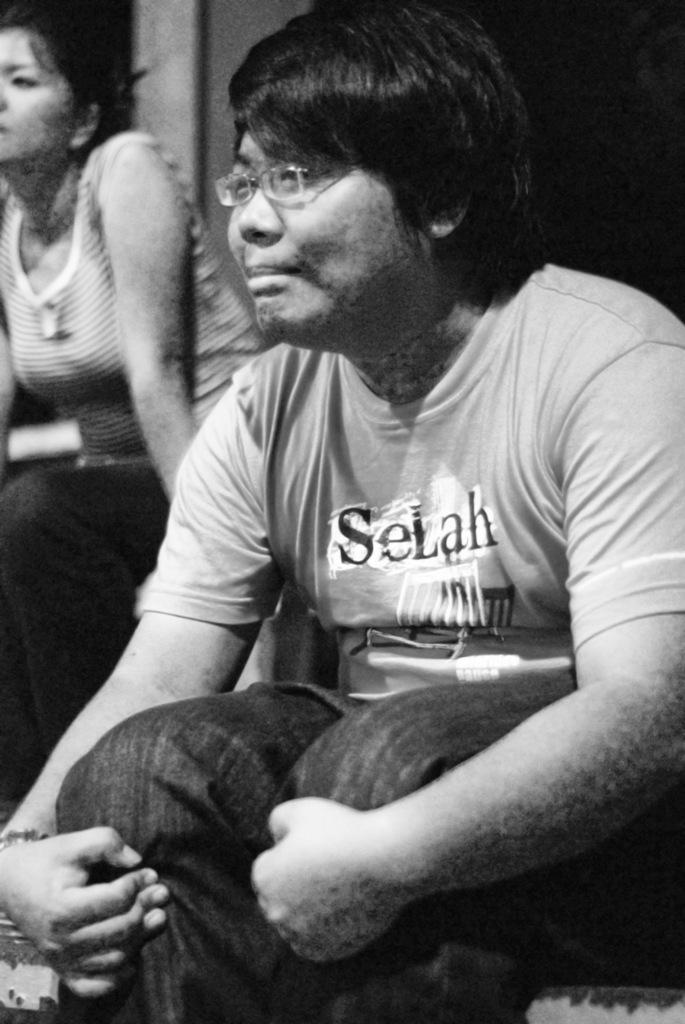What is the man in the image doing? The man is sitting in the image. Where is the man located in relation to the image? The man is in the foreground area of the image. What else can be seen in the image besides the man? There is a lady in the image. Where is the lady located in relation to the image? The lady is in the background of the image. What type of egg can be seen in the bucket in the image? There is no bucket or egg present in the image. What is the pail used for in the image? There is no pail present in the image. 